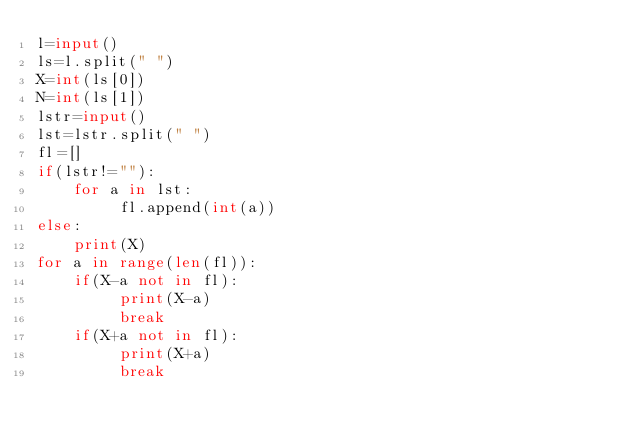<code> <loc_0><loc_0><loc_500><loc_500><_Python_>l=input()
ls=l.split(" ")
X=int(ls[0])
N=int(ls[1])
lstr=input()
lst=lstr.split(" ")
fl=[]
if(lstr!=""):
    for a in lst:
         fl.append(int(a))
else:
    print(X)
for a in range(len(fl)):
    if(X-a not in fl):
         print(X-a)
         break
    if(X+a not in fl):
         print(X+a)
         break</code> 